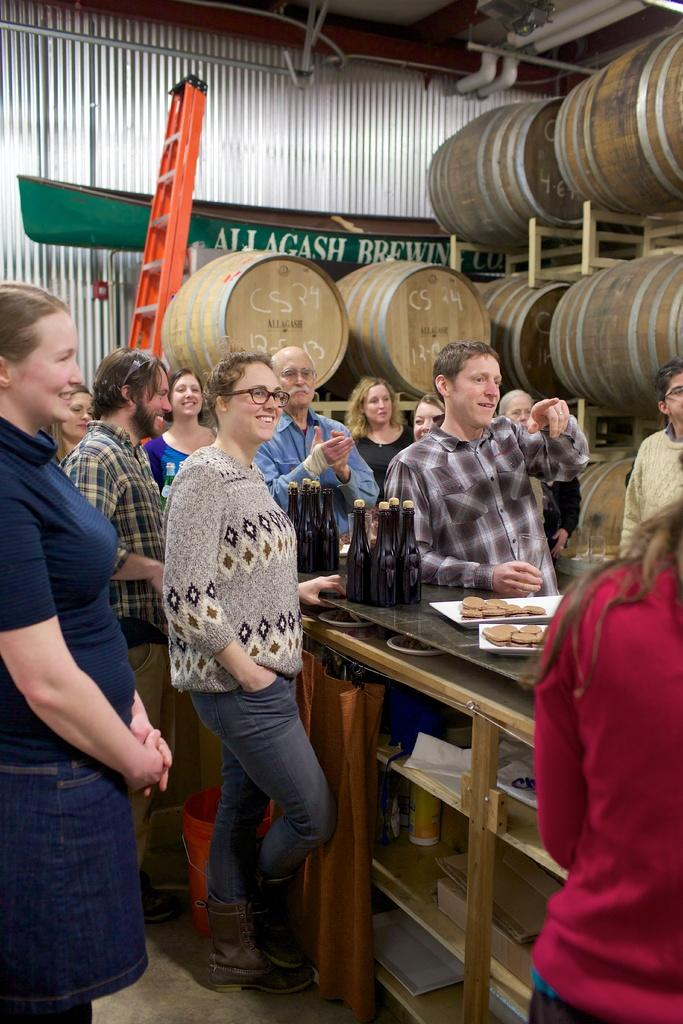How many people are in the image? There are many people in the image. What are the people doing in the image? The people are standing and laughing. Are there any people clapping in the image? Yes, some people are clapping in the image. What is on the table in the image? There is a table in the image with bottles and a plate of biscuits. What type of machine is visible on the side of the image? There is no machine visible in the image. How low are the people sitting in the image? The people are not sitting in the image; they are standing. 